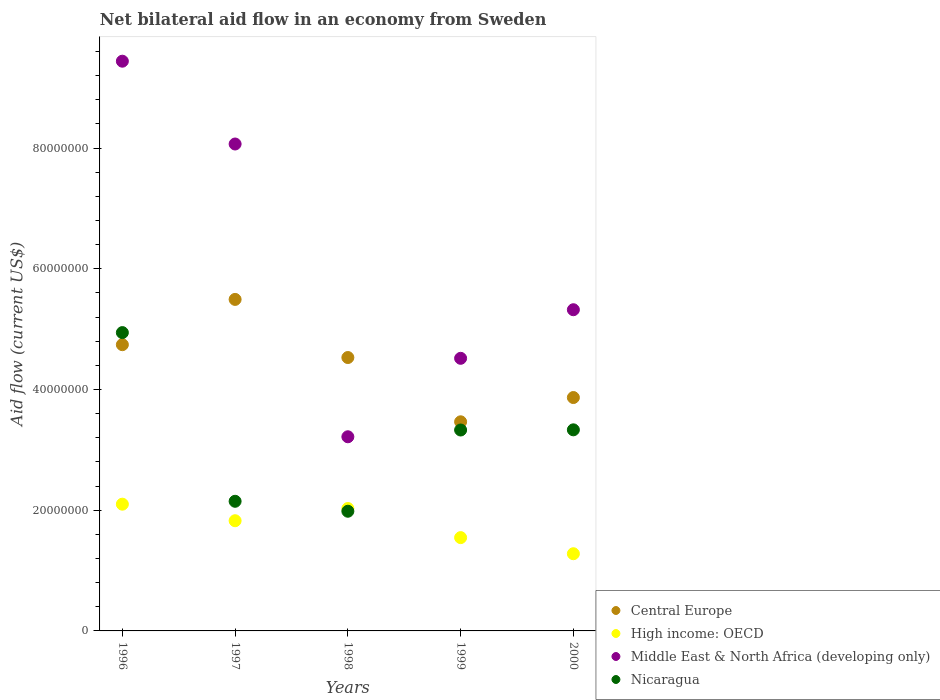Is the number of dotlines equal to the number of legend labels?
Give a very brief answer. Yes. What is the net bilateral aid flow in Middle East & North Africa (developing only) in 1998?
Your answer should be compact. 3.22e+07. Across all years, what is the maximum net bilateral aid flow in Central Europe?
Make the answer very short. 5.49e+07. Across all years, what is the minimum net bilateral aid flow in Nicaragua?
Ensure brevity in your answer.  1.98e+07. In which year was the net bilateral aid flow in High income: OECD maximum?
Offer a very short reply. 1996. What is the total net bilateral aid flow in Middle East & North Africa (developing only) in the graph?
Give a very brief answer. 3.06e+08. What is the difference between the net bilateral aid flow in Central Europe in 1999 and that in 2000?
Offer a terse response. -4.02e+06. What is the difference between the net bilateral aid flow in Central Europe in 2000 and the net bilateral aid flow in High income: OECD in 1996?
Your answer should be compact. 1.77e+07. What is the average net bilateral aid flow in Middle East & North Africa (developing only) per year?
Provide a succinct answer. 6.11e+07. In the year 1999, what is the difference between the net bilateral aid flow in Nicaragua and net bilateral aid flow in High income: OECD?
Keep it short and to the point. 1.78e+07. In how many years, is the net bilateral aid flow in Nicaragua greater than 68000000 US$?
Your response must be concise. 0. What is the ratio of the net bilateral aid flow in Central Europe in 1997 to that in 1998?
Provide a short and direct response. 1.21. Is the difference between the net bilateral aid flow in Nicaragua in 1996 and 1999 greater than the difference between the net bilateral aid flow in High income: OECD in 1996 and 1999?
Your answer should be very brief. Yes. What is the difference between the highest and the second highest net bilateral aid flow in Central Europe?
Ensure brevity in your answer.  7.50e+06. What is the difference between the highest and the lowest net bilateral aid flow in High income: OECD?
Give a very brief answer. 8.21e+06. In how many years, is the net bilateral aid flow in High income: OECD greater than the average net bilateral aid flow in High income: OECD taken over all years?
Make the answer very short. 3. Is it the case that in every year, the sum of the net bilateral aid flow in Nicaragua and net bilateral aid flow in Central Europe  is greater than the net bilateral aid flow in High income: OECD?
Make the answer very short. Yes. Does the net bilateral aid flow in High income: OECD monotonically increase over the years?
Provide a succinct answer. No. Is the net bilateral aid flow in Central Europe strictly less than the net bilateral aid flow in Middle East & North Africa (developing only) over the years?
Offer a terse response. No. How many dotlines are there?
Give a very brief answer. 4. How many years are there in the graph?
Offer a terse response. 5. Does the graph contain any zero values?
Give a very brief answer. No. What is the title of the graph?
Give a very brief answer. Net bilateral aid flow in an economy from Sweden. Does "Europe(developing only)" appear as one of the legend labels in the graph?
Your answer should be compact. No. What is the label or title of the Y-axis?
Provide a succinct answer. Aid flow (current US$). What is the Aid flow (current US$) of Central Europe in 1996?
Provide a short and direct response. 4.74e+07. What is the Aid flow (current US$) of High income: OECD in 1996?
Offer a terse response. 2.10e+07. What is the Aid flow (current US$) in Middle East & North Africa (developing only) in 1996?
Offer a very short reply. 9.44e+07. What is the Aid flow (current US$) of Nicaragua in 1996?
Ensure brevity in your answer.  4.94e+07. What is the Aid flow (current US$) in Central Europe in 1997?
Provide a succinct answer. 5.49e+07. What is the Aid flow (current US$) in High income: OECD in 1997?
Give a very brief answer. 1.83e+07. What is the Aid flow (current US$) in Middle East & North Africa (developing only) in 1997?
Your answer should be very brief. 8.07e+07. What is the Aid flow (current US$) of Nicaragua in 1997?
Keep it short and to the point. 2.15e+07. What is the Aid flow (current US$) of Central Europe in 1998?
Your answer should be compact. 4.53e+07. What is the Aid flow (current US$) in High income: OECD in 1998?
Offer a terse response. 2.03e+07. What is the Aid flow (current US$) of Middle East & North Africa (developing only) in 1998?
Make the answer very short. 3.22e+07. What is the Aid flow (current US$) of Nicaragua in 1998?
Give a very brief answer. 1.98e+07. What is the Aid flow (current US$) in Central Europe in 1999?
Your answer should be very brief. 3.46e+07. What is the Aid flow (current US$) in High income: OECD in 1999?
Offer a terse response. 1.55e+07. What is the Aid flow (current US$) of Middle East & North Africa (developing only) in 1999?
Ensure brevity in your answer.  4.52e+07. What is the Aid flow (current US$) of Nicaragua in 1999?
Provide a succinct answer. 3.33e+07. What is the Aid flow (current US$) of Central Europe in 2000?
Ensure brevity in your answer.  3.87e+07. What is the Aid flow (current US$) of High income: OECD in 2000?
Your answer should be compact. 1.28e+07. What is the Aid flow (current US$) of Middle East & North Africa (developing only) in 2000?
Give a very brief answer. 5.32e+07. What is the Aid flow (current US$) in Nicaragua in 2000?
Offer a terse response. 3.33e+07. Across all years, what is the maximum Aid flow (current US$) of Central Europe?
Ensure brevity in your answer.  5.49e+07. Across all years, what is the maximum Aid flow (current US$) in High income: OECD?
Your answer should be very brief. 2.10e+07. Across all years, what is the maximum Aid flow (current US$) in Middle East & North Africa (developing only)?
Offer a very short reply. 9.44e+07. Across all years, what is the maximum Aid flow (current US$) of Nicaragua?
Keep it short and to the point. 4.94e+07. Across all years, what is the minimum Aid flow (current US$) of Central Europe?
Keep it short and to the point. 3.46e+07. Across all years, what is the minimum Aid flow (current US$) in High income: OECD?
Provide a short and direct response. 1.28e+07. Across all years, what is the minimum Aid flow (current US$) in Middle East & North Africa (developing only)?
Offer a very short reply. 3.22e+07. Across all years, what is the minimum Aid flow (current US$) in Nicaragua?
Your answer should be very brief. 1.98e+07. What is the total Aid flow (current US$) of Central Europe in the graph?
Make the answer very short. 2.21e+08. What is the total Aid flow (current US$) in High income: OECD in the graph?
Your answer should be very brief. 8.78e+07. What is the total Aid flow (current US$) in Middle East & North Africa (developing only) in the graph?
Keep it short and to the point. 3.06e+08. What is the total Aid flow (current US$) of Nicaragua in the graph?
Your answer should be very brief. 1.57e+08. What is the difference between the Aid flow (current US$) in Central Europe in 1996 and that in 1997?
Provide a short and direct response. -7.50e+06. What is the difference between the Aid flow (current US$) of High income: OECD in 1996 and that in 1997?
Provide a succinct answer. 2.74e+06. What is the difference between the Aid flow (current US$) in Middle East & North Africa (developing only) in 1996 and that in 1997?
Offer a terse response. 1.37e+07. What is the difference between the Aid flow (current US$) of Nicaragua in 1996 and that in 1997?
Offer a terse response. 2.80e+07. What is the difference between the Aid flow (current US$) of Central Europe in 1996 and that in 1998?
Offer a terse response. 2.13e+06. What is the difference between the Aid flow (current US$) in High income: OECD in 1996 and that in 1998?
Provide a succinct answer. 7.20e+05. What is the difference between the Aid flow (current US$) in Middle East & North Africa (developing only) in 1996 and that in 1998?
Your answer should be compact. 6.22e+07. What is the difference between the Aid flow (current US$) in Nicaragua in 1996 and that in 1998?
Your answer should be compact. 2.96e+07. What is the difference between the Aid flow (current US$) in Central Europe in 1996 and that in 1999?
Your answer should be very brief. 1.28e+07. What is the difference between the Aid flow (current US$) of High income: OECD in 1996 and that in 1999?
Keep it short and to the point. 5.54e+06. What is the difference between the Aid flow (current US$) in Middle East & North Africa (developing only) in 1996 and that in 1999?
Ensure brevity in your answer.  4.92e+07. What is the difference between the Aid flow (current US$) in Nicaragua in 1996 and that in 1999?
Your response must be concise. 1.61e+07. What is the difference between the Aid flow (current US$) of Central Europe in 1996 and that in 2000?
Your answer should be compact. 8.76e+06. What is the difference between the Aid flow (current US$) in High income: OECD in 1996 and that in 2000?
Your answer should be compact. 8.21e+06. What is the difference between the Aid flow (current US$) of Middle East & North Africa (developing only) in 1996 and that in 2000?
Your response must be concise. 4.12e+07. What is the difference between the Aid flow (current US$) in Nicaragua in 1996 and that in 2000?
Keep it short and to the point. 1.61e+07. What is the difference between the Aid flow (current US$) in Central Europe in 1997 and that in 1998?
Provide a succinct answer. 9.63e+06. What is the difference between the Aid flow (current US$) in High income: OECD in 1997 and that in 1998?
Provide a short and direct response. -2.02e+06. What is the difference between the Aid flow (current US$) of Middle East & North Africa (developing only) in 1997 and that in 1998?
Your response must be concise. 4.85e+07. What is the difference between the Aid flow (current US$) of Nicaragua in 1997 and that in 1998?
Your answer should be very brief. 1.65e+06. What is the difference between the Aid flow (current US$) in Central Europe in 1997 and that in 1999?
Provide a succinct answer. 2.03e+07. What is the difference between the Aid flow (current US$) of High income: OECD in 1997 and that in 1999?
Your answer should be very brief. 2.80e+06. What is the difference between the Aid flow (current US$) of Middle East & North Africa (developing only) in 1997 and that in 1999?
Ensure brevity in your answer.  3.55e+07. What is the difference between the Aid flow (current US$) in Nicaragua in 1997 and that in 1999?
Offer a very short reply. -1.18e+07. What is the difference between the Aid flow (current US$) in Central Europe in 1997 and that in 2000?
Your response must be concise. 1.63e+07. What is the difference between the Aid flow (current US$) of High income: OECD in 1997 and that in 2000?
Provide a succinct answer. 5.47e+06. What is the difference between the Aid flow (current US$) of Middle East & North Africa (developing only) in 1997 and that in 2000?
Your answer should be compact. 2.75e+07. What is the difference between the Aid flow (current US$) of Nicaragua in 1997 and that in 2000?
Keep it short and to the point. -1.18e+07. What is the difference between the Aid flow (current US$) in Central Europe in 1998 and that in 1999?
Make the answer very short. 1.06e+07. What is the difference between the Aid flow (current US$) in High income: OECD in 1998 and that in 1999?
Keep it short and to the point. 4.82e+06. What is the difference between the Aid flow (current US$) of Middle East & North Africa (developing only) in 1998 and that in 1999?
Offer a very short reply. -1.30e+07. What is the difference between the Aid flow (current US$) in Nicaragua in 1998 and that in 1999?
Offer a terse response. -1.35e+07. What is the difference between the Aid flow (current US$) in Central Europe in 1998 and that in 2000?
Make the answer very short. 6.63e+06. What is the difference between the Aid flow (current US$) of High income: OECD in 1998 and that in 2000?
Your answer should be compact. 7.49e+06. What is the difference between the Aid flow (current US$) of Middle East & North Africa (developing only) in 1998 and that in 2000?
Your answer should be very brief. -2.10e+07. What is the difference between the Aid flow (current US$) in Nicaragua in 1998 and that in 2000?
Your response must be concise. -1.35e+07. What is the difference between the Aid flow (current US$) of Central Europe in 1999 and that in 2000?
Provide a short and direct response. -4.02e+06. What is the difference between the Aid flow (current US$) in High income: OECD in 1999 and that in 2000?
Make the answer very short. 2.67e+06. What is the difference between the Aid flow (current US$) in Middle East & North Africa (developing only) in 1999 and that in 2000?
Ensure brevity in your answer.  -8.05e+06. What is the difference between the Aid flow (current US$) of Nicaragua in 1999 and that in 2000?
Provide a short and direct response. -3.00e+04. What is the difference between the Aid flow (current US$) in Central Europe in 1996 and the Aid flow (current US$) in High income: OECD in 1997?
Ensure brevity in your answer.  2.92e+07. What is the difference between the Aid flow (current US$) in Central Europe in 1996 and the Aid flow (current US$) in Middle East & North Africa (developing only) in 1997?
Your response must be concise. -3.32e+07. What is the difference between the Aid flow (current US$) in Central Europe in 1996 and the Aid flow (current US$) in Nicaragua in 1997?
Provide a short and direct response. 2.60e+07. What is the difference between the Aid flow (current US$) in High income: OECD in 1996 and the Aid flow (current US$) in Middle East & North Africa (developing only) in 1997?
Give a very brief answer. -5.97e+07. What is the difference between the Aid flow (current US$) in High income: OECD in 1996 and the Aid flow (current US$) in Nicaragua in 1997?
Your answer should be very brief. -4.80e+05. What is the difference between the Aid flow (current US$) in Middle East & North Africa (developing only) in 1996 and the Aid flow (current US$) in Nicaragua in 1997?
Make the answer very short. 7.29e+07. What is the difference between the Aid flow (current US$) in Central Europe in 1996 and the Aid flow (current US$) in High income: OECD in 1998?
Offer a terse response. 2.72e+07. What is the difference between the Aid flow (current US$) in Central Europe in 1996 and the Aid flow (current US$) in Middle East & North Africa (developing only) in 1998?
Offer a very short reply. 1.53e+07. What is the difference between the Aid flow (current US$) in Central Europe in 1996 and the Aid flow (current US$) in Nicaragua in 1998?
Ensure brevity in your answer.  2.76e+07. What is the difference between the Aid flow (current US$) in High income: OECD in 1996 and the Aid flow (current US$) in Middle East & North Africa (developing only) in 1998?
Your response must be concise. -1.12e+07. What is the difference between the Aid flow (current US$) in High income: OECD in 1996 and the Aid flow (current US$) in Nicaragua in 1998?
Ensure brevity in your answer.  1.17e+06. What is the difference between the Aid flow (current US$) of Middle East & North Africa (developing only) in 1996 and the Aid flow (current US$) of Nicaragua in 1998?
Give a very brief answer. 7.46e+07. What is the difference between the Aid flow (current US$) of Central Europe in 1996 and the Aid flow (current US$) of High income: OECD in 1999?
Your answer should be compact. 3.20e+07. What is the difference between the Aid flow (current US$) of Central Europe in 1996 and the Aid flow (current US$) of Middle East & North Africa (developing only) in 1999?
Provide a short and direct response. 2.26e+06. What is the difference between the Aid flow (current US$) of Central Europe in 1996 and the Aid flow (current US$) of Nicaragua in 1999?
Offer a terse response. 1.41e+07. What is the difference between the Aid flow (current US$) of High income: OECD in 1996 and the Aid flow (current US$) of Middle East & North Africa (developing only) in 1999?
Offer a terse response. -2.42e+07. What is the difference between the Aid flow (current US$) in High income: OECD in 1996 and the Aid flow (current US$) in Nicaragua in 1999?
Offer a very short reply. -1.23e+07. What is the difference between the Aid flow (current US$) in Middle East & North Africa (developing only) in 1996 and the Aid flow (current US$) in Nicaragua in 1999?
Keep it short and to the point. 6.11e+07. What is the difference between the Aid flow (current US$) in Central Europe in 1996 and the Aid flow (current US$) in High income: OECD in 2000?
Ensure brevity in your answer.  3.46e+07. What is the difference between the Aid flow (current US$) in Central Europe in 1996 and the Aid flow (current US$) in Middle East & North Africa (developing only) in 2000?
Your answer should be compact. -5.79e+06. What is the difference between the Aid flow (current US$) of Central Europe in 1996 and the Aid flow (current US$) of Nicaragua in 2000?
Keep it short and to the point. 1.41e+07. What is the difference between the Aid flow (current US$) of High income: OECD in 1996 and the Aid flow (current US$) of Middle East & North Africa (developing only) in 2000?
Provide a short and direct response. -3.22e+07. What is the difference between the Aid flow (current US$) of High income: OECD in 1996 and the Aid flow (current US$) of Nicaragua in 2000?
Your answer should be compact. -1.23e+07. What is the difference between the Aid flow (current US$) of Middle East & North Africa (developing only) in 1996 and the Aid flow (current US$) of Nicaragua in 2000?
Your answer should be very brief. 6.11e+07. What is the difference between the Aid flow (current US$) of Central Europe in 1997 and the Aid flow (current US$) of High income: OECD in 1998?
Provide a succinct answer. 3.46e+07. What is the difference between the Aid flow (current US$) of Central Europe in 1997 and the Aid flow (current US$) of Middle East & North Africa (developing only) in 1998?
Offer a terse response. 2.28e+07. What is the difference between the Aid flow (current US$) in Central Europe in 1997 and the Aid flow (current US$) in Nicaragua in 1998?
Give a very brief answer. 3.51e+07. What is the difference between the Aid flow (current US$) of High income: OECD in 1997 and the Aid flow (current US$) of Middle East & North Africa (developing only) in 1998?
Your response must be concise. -1.39e+07. What is the difference between the Aid flow (current US$) in High income: OECD in 1997 and the Aid flow (current US$) in Nicaragua in 1998?
Your answer should be compact. -1.57e+06. What is the difference between the Aid flow (current US$) in Middle East & North Africa (developing only) in 1997 and the Aid flow (current US$) in Nicaragua in 1998?
Offer a very short reply. 6.08e+07. What is the difference between the Aid flow (current US$) in Central Europe in 1997 and the Aid flow (current US$) in High income: OECD in 1999?
Provide a short and direct response. 3.95e+07. What is the difference between the Aid flow (current US$) of Central Europe in 1997 and the Aid flow (current US$) of Middle East & North Africa (developing only) in 1999?
Make the answer very short. 9.76e+06. What is the difference between the Aid flow (current US$) of Central Europe in 1997 and the Aid flow (current US$) of Nicaragua in 1999?
Offer a very short reply. 2.16e+07. What is the difference between the Aid flow (current US$) of High income: OECD in 1997 and the Aid flow (current US$) of Middle East & North Africa (developing only) in 1999?
Your answer should be very brief. -2.69e+07. What is the difference between the Aid flow (current US$) of High income: OECD in 1997 and the Aid flow (current US$) of Nicaragua in 1999?
Provide a short and direct response. -1.50e+07. What is the difference between the Aid flow (current US$) in Middle East & North Africa (developing only) in 1997 and the Aid flow (current US$) in Nicaragua in 1999?
Offer a very short reply. 4.74e+07. What is the difference between the Aid flow (current US$) in Central Europe in 1997 and the Aid flow (current US$) in High income: OECD in 2000?
Your answer should be very brief. 4.21e+07. What is the difference between the Aid flow (current US$) in Central Europe in 1997 and the Aid flow (current US$) in Middle East & North Africa (developing only) in 2000?
Make the answer very short. 1.71e+06. What is the difference between the Aid flow (current US$) in Central Europe in 1997 and the Aid flow (current US$) in Nicaragua in 2000?
Ensure brevity in your answer.  2.16e+07. What is the difference between the Aid flow (current US$) in High income: OECD in 1997 and the Aid flow (current US$) in Middle East & North Africa (developing only) in 2000?
Offer a terse response. -3.50e+07. What is the difference between the Aid flow (current US$) in High income: OECD in 1997 and the Aid flow (current US$) in Nicaragua in 2000?
Make the answer very short. -1.51e+07. What is the difference between the Aid flow (current US$) of Middle East & North Africa (developing only) in 1997 and the Aid flow (current US$) of Nicaragua in 2000?
Offer a terse response. 4.74e+07. What is the difference between the Aid flow (current US$) in Central Europe in 1998 and the Aid flow (current US$) in High income: OECD in 1999?
Make the answer very short. 2.98e+07. What is the difference between the Aid flow (current US$) in Central Europe in 1998 and the Aid flow (current US$) in Nicaragua in 1999?
Your answer should be very brief. 1.20e+07. What is the difference between the Aid flow (current US$) of High income: OECD in 1998 and the Aid flow (current US$) of Middle East & North Africa (developing only) in 1999?
Ensure brevity in your answer.  -2.49e+07. What is the difference between the Aid flow (current US$) in High income: OECD in 1998 and the Aid flow (current US$) in Nicaragua in 1999?
Your answer should be very brief. -1.30e+07. What is the difference between the Aid flow (current US$) in Middle East & North Africa (developing only) in 1998 and the Aid flow (current US$) in Nicaragua in 1999?
Your response must be concise. -1.12e+06. What is the difference between the Aid flow (current US$) in Central Europe in 1998 and the Aid flow (current US$) in High income: OECD in 2000?
Offer a terse response. 3.25e+07. What is the difference between the Aid flow (current US$) of Central Europe in 1998 and the Aid flow (current US$) of Middle East & North Africa (developing only) in 2000?
Your answer should be compact. -7.92e+06. What is the difference between the Aid flow (current US$) in Central Europe in 1998 and the Aid flow (current US$) in Nicaragua in 2000?
Offer a terse response. 1.20e+07. What is the difference between the Aid flow (current US$) of High income: OECD in 1998 and the Aid flow (current US$) of Middle East & North Africa (developing only) in 2000?
Offer a very short reply. -3.29e+07. What is the difference between the Aid flow (current US$) in High income: OECD in 1998 and the Aid flow (current US$) in Nicaragua in 2000?
Provide a short and direct response. -1.30e+07. What is the difference between the Aid flow (current US$) of Middle East & North Africa (developing only) in 1998 and the Aid flow (current US$) of Nicaragua in 2000?
Ensure brevity in your answer.  -1.15e+06. What is the difference between the Aid flow (current US$) of Central Europe in 1999 and the Aid flow (current US$) of High income: OECD in 2000?
Provide a short and direct response. 2.19e+07. What is the difference between the Aid flow (current US$) in Central Europe in 1999 and the Aid flow (current US$) in Middle East & North Africa (developing only) in 2000?
Your answer should be compact. -1.86e+07. What is the difference between the Aid flow (current US$) of Central Europe in 1999 and the Aid flow (current US$) of Nicaragua in 2000?
Offer a terse response. 1.33e+06. What is the difference between the Aid flow (current US$) of High income: OECD in 1999 and the Aid flow (current US$) of Middle East & North Africa (developing only) in 2000?
Your answer should be compact. -3.78e+07. What is the difference between the Aid flow (current US$) of High income: OECD in 1999 and the Aid flow (current US$) of Nicaragua in 2000?
Ensure brevity in your answer.  -1.79e+07. What is the difference between the Aid flow (current US$) in Middle East & North Africa (developing only) in 1999 and the Aid flow (current US$) in Nicaragua in 2000?
Provide a short and direct response. 1.18e+07. What is the average Aid flow (current US$) in Central Europe per year?
Ensure brevity in your answer.  4.42e+07. What is the average Aid flow (current US$) in High income: OECD per year?
Ensure brevity in your answer.  1.76e+07. What is the average Aid flow (current US$) in Middle East & North Africa (developing only) per year?
Your answer should be very brief. 6.11e+07. What is the average Aid flow (current US$) in Nicaragua per year?
Make the answer very short. 3.15e+07. In the year 1996, what is the difference between the Aid flow (current US$) of Central Europe and Aid flow (current US$) of High income: OECD?
Offer a very short reply. 2.64e+07. In the year 1996, what is the difference between the Aid flow (current US$) in Central Europe and Aid flow (current US$) in Middle East & North Africa (developing only)?
Provide a succinct answer. -4.70e+07. In the year 1996, what is the difference between the Aid flow (current US$) of High income: OECD and Aid flow (current US$) of Middle East & North Africa (developing only)?
Provide a succinct answer. -7.34e+07. In the year 1996, what is the difference between the Aid flow (current US$) in High income: OECD and Aid flow (current US$) in Nicaragua?
Your answer should be compact. -2.84e+07. In the year 1996, what is the difference between the Aid flow (current US$) of Middle East & North Africa (developing only) and Aid flow (current US$) of Nicaragua?
Your answer should be compact. 4.50e+07. In the year 1997, what is the difference between the Aid flow (current US$) of Central Europe and Aid flow (current US$) of High income: OECD?
Provide a succinct answer. 3.67e+07. In the year 1997, what is the difference between the Aid flow (current US$) of Central Europe and Aid flow (current US$) of Middle East & North Africa (developing only)?
Keep it short and to the point. -2.58e+07. In the year 1997, what is the difference between the Aid flow (current US$) of Central Europe and Aid flow (current US$) of Nicaragua?
Make the answer very short. 3.34e+07. In the year 1997, what is the difference between the Aid flow (current US$) in High income: OECD and Aid flow (current US$) in Middle East & North Africa (developing only)?
Your response must be concise. -6.24e+07. In the year 1997, what is the difference between the Aid flow (current US$) of High income: OECD and Aid flow (current US$) of Nicaragua?
Offer a terse response. -3.22e+06. In the year 1997, what is the difference between the Aid flow (current US$) of Middle East & North Africa (developing only) and Aid flow (current US$) of Nicaragua?
Ensure brevity in your answer.  5.92e+07. In the year 1998, what is the difference between the Aid flow (current US$) of Central Europe and Aid flow (current US$) of High income: OECD?
Provide a short and direct response. 2.50e+07. In the year 1998, what is the difference between the Aid flow (current US$) of Central Europe and Aid flow (current US$) of Middle East & North Africa (developing only)?
Make the answer very short. 1.31e+07. In the year 1998, what is the difference between the Aid flow (current US$) of Central Europe and Aid flow (current US$) of Nicaragua?
Your response must be concise. 2.55e+07. In the year 1998, what is the difference between the Aid flow (current US$) in High income: OECD and Aid flow (current US$) in Middle East & North Africa (developing only)?
Offer a very short reply. -1.19e+07. In the year 1998, what is the difference between the Aid flow (current US$) in Middle East & North Africa (developing only) and Aid flow (current US$) in Nicaragua?
Keep it short and to the point. 1.23e+07. In the year 1999, what is the difference between the Aid flow (current US$) of Central Europe and Aid flow (current US$) of High income: OECD?
Ensure brevity in your answer.  1.92e+07. In the year 1999, what is the difference between the Aid flow (current US$) of Central Europe and Aid flow (current US$) of Middle East & North Africa (developing only)?
Provide a short and direct response. -1.05e+07. In the year 1999, what is the difference between the Aid flow (current US$) in Central Europe and Aid flow (current US$) in Nicaragua?
Give a very brief answer. 1.36e+06. In the year 1999, what is the difference between the Aid flow (current US$) in High income: OECD and Aid flow (current US$) in Middle East & North Africa (developing only)?
Offer a terse response. -2.97e+07. In the year 1999, what is the difference between the Aid flow (current US$) in High income: OECD and Aid flow (current US$) in Nicaragua?
Offer a terse response. -1.78e+07. In the year 1999, what is the difference between the Aid flow (current US$) of Middle East & North Africa (developing only) and Aid flow (current US$) of Nicaragua?
Provide a succinct answer. 1.19e+07. In the year 2000, what is the difference between the Aid flow (current US$) in Central Europe and Aid flow (current US$) in High income: OECD?
Ensure brevity in your answer.  2.59e+07. In the year 2000, what is the difference between the Aid flow (current US$) in Central Europe and Aid flow (current US$) in Middle East & North Africa (developing only)?
Provide a short and direct response. -1.46e+07. In the year 2000, what is the difference between the Aid flow (current US$) in Central Europe and Aid flow (current US$) in Nicaragua?
Your response must be concise. 5.35e+06. In the year 2000, what is the difference between the Aid flow (current US$) in High income: OECD and Aid flow (current US$) in Middle East & North Africa (developing only)?
Make the answer very short. -4.04e+07. In the year 2000, what is the difference between the Aid flow (current US$) in High income: OECD and Aid flow (current US$) in Nicaragua?
Make the answer very short. -2.05e+07. In the year 2000, what is the difference between the Aid flow (current US$) of Middle East & North Africa (developing only) and Aid flow (current US$) of Nicaragua?
Your answer should be very brief. 1.99e+07. What is the ratio of the Aid flow (current US$) of Central Europe in 1996 to that in 1997?
Your answer should be very brief. 0.86. What is the ratio of the Aid flow (current US$) in High income: OECD in 1996 to that in 1997?
Your answer should be compact. 1.15. What is the ratio of the Aid flow (current US$) in Middle East & North Africa (developing only) in 1996 to that in 1997?
Make the answer very short. 1.17. What is the ratio of the Aid flow (current US$) in Nicaragua in 1996 to that in 1997?
Give a very brief answer. 2.3. What is the ratio of the Aid flow (current US$) in Central Europe in 1996 to that in 1998?
Provide a short and direct response. 1.05. What is the ratio of the Aid flow (current US$) in High income: OECD in 1996 to that in 1998?
Give a very brief answer. 1.04. What is the ratio of the Aid flow (current US$) in Middle East & North Africa (developing only) in 1996 to that in 1998?
Offer a very short reply. 2.93. What is the ratio of the Aid flow (current US$) of Nicaragua in 1996 to that in 1998?
Your answer should be very brief. 2.49. What is the ratio of the Aid flow (current US$) in Central Europe in 1996 to that in 1999?
Ensure brevity in your answer.  1.37. What is the ratio of the Aid flow (current US$) in High income: OECD in 1996 to that in 1999?
Your response must be concise. 1.36. What is the ratio of the Aid flow (current US$) of Middle East & North Africa (developing only) in 1996 to that in 1999?
Offer a very short reply. 2.09. What is the ratio of the Aid flow (current US$) of Nicaragua in 1996 to that in 1999?
Provide a succinct answer. 1.48. What is the ratio of the Aid flow (current US$) in Central Europe in 1996 to that in 2000?
Provide a succinct answer. 1.23. What is the ratio of the Aid flow (current US$) in High income: OECD in 1996 to that in 2000?
Provide a short and direct response. 1.64. What is the ratio of the Aid flow (current US$) in Middle East & North Africa (developing only) in 1996 to that in 2000?
Offer a very short reply. 1.77. What is the ratio of the Aid flow (current US$) in Nicaragua in 1996 to that in 2000?
Offer a very short reply. 1.48. What is the ratio of the Aid flow (current US$) of Central Europe in 1997 to that in 1998?
Keep it short and to the point. 1.21. What is the ratio of the Aid flow (current US$) of High income: OECD in 1997 to that in 1998?
Your response must be concise. 0.9. What is the ratio of the Aid flow (current US$) in Middle East & North Africa (developing only) in 1997 to that in 1998?
Provide a short and direct response. 2.51. What is the ratio of the Aid flow (current US$) of Nicaragua in 1997 to that in 1998?
Provide a succinct answer. 1.08. What is the ratio of the Aid flow (current US$) in Central Europe in 1997 to that in 1999?
Provide a succinct answer. 1.59. What is the ratio of the Aid flow (current US$) in High income: OECD in 1997 to that in 1999?
Keep it short and to the point. 1.18. What is the ratio of the Aid flow (current US$) of Middle East & North Africa (developing only) in 1997 to that in 1999?
Your response must be concise. 1.79. What is the ratio of the Aid flow (current US$) of Nicaragua in 1997 to that in 1999?
Your answer should be compact. 0.65. What is the ratio of the Aid flow (current US$) of Central Europe in 1997 to that in 2000?
Offer a terse response. 1.42. What is the ratio of the Aid flow (current US$) in High income: OECD in 1997 to that in 2000?
Offer a terse response. 1.43. What is the ratio of the Aid flow (current US$) of Middle East & North Africa (developing only) in 1997 to that in 2000?
Your answer should be compact. 1.52. What is the ratio of the Aid flow (current US$) in Nicaragua in 1997 to that in 2000?
Your response must be concise. 0.64. What is the ratio of the Aid flow (current US$) in Central Europe in 1998 to that in 1999?
Provide a succinct answer. 1.31. What is the ratio of the Aid flow (current US$) of High income: OECD in 1998 to that in 1999?
Provide a succinct answer. 1.31. What is the ratio of the Aid flow (current US$) in Middle East & North Africa (developing only) in 1998 to that in 1999?
Ensure brevity in your answer.  0.71. What is the ratio of the Aid flow (current US$) of Nicaragua in 1998 to that in 1999?
Provide a succinct answer. 0.6. What is the ratio of the Aid flow (current US$) of Central Europe in 1998 to that in 2000?
Provide a short and direct response. 1.17. What is the ratio of the Aid flow (current US$) of High income: OECD in 1998 to that in 2000?
Ensure brevity in your answer.  1.59. What is the ratio of the Aid flow (current US$) of Middle East & North Africa (developing only) in 1998 to that in 2000?
Provide a short and direct response. 0.6. What is the ratio of the Aid flow (current US$) of Nicaragua in 1998 to that in 2000?
Your response must be concise. 0.6. What is the ratio of the Aid flow (current US$) in Central Europe in 1999 to that in 2000?
Your answer should be compact. 0.9. What is the ratio of the Aid flow (current US$) of High income: OECD in 1999 to that in 2000?
Your answer should be very brief. 1.21. What is the ratio of the Aid flow (current US$) in Middle East & North Africa (developing only) in 1999 to that in 2000?
Offer a very short reply. 0.85. What is the ratio of the Aid flow (current US$) of Nicaragua in 1999 to that in 2000?
Ensure brevity in your answer.  1. What is the difference between the highest and the second highest Aid flow (current US$) of Central Europe?
Your response must be concise. 7.50e+06. What is the difference between the highest and the second highest Aid flow (current US$) in High income: OECD?
Offer a terse response. 7.20e+05. What is the difference between the highest and the second highest Aid flow (current US$) in Middle East & North Africa (developing only)?
Ensure brevity in your answer.  1.37e+07. What is the difference between the highest and the second highest Aid flow (current US$) in Nicaragua?
Provide a succinct answer. 1.61e+07. What is the difference between the highest and the lowest Aid flow (current US$) in Central Europe?
Ensure brevity in your answer.  2.03e+07. What is the difference between the highest and the lowest Aid flow (current US$) of High income: OECD?
Your answer should be very brief. 8.21e+06. What is the difference between the highest and the lowest Aid flow (current US$) of Middle East & North Africa (developing only)?
Keep it short and to the point. 6.22e+07. What is the difference between the highest and the lowest Aid flow (current US$) of Nicaragua?
Make the answer very short. 2.96e+07. 